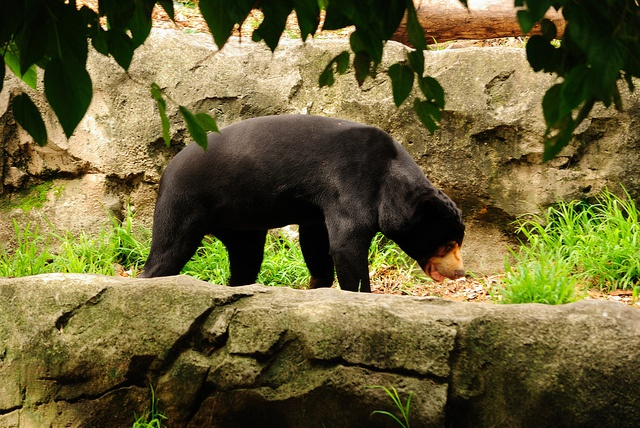Describe the objects in this image and their specific colors. I can see a bear in black and gray tones in this image. 